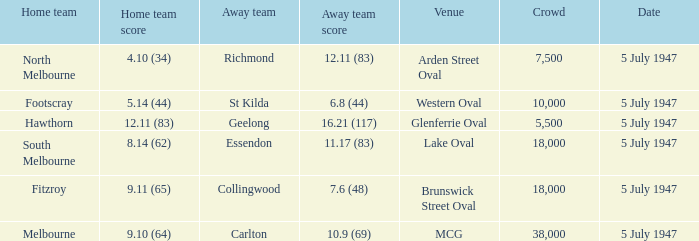Who was the away team when North Melbourne was the home team? Richmond. 